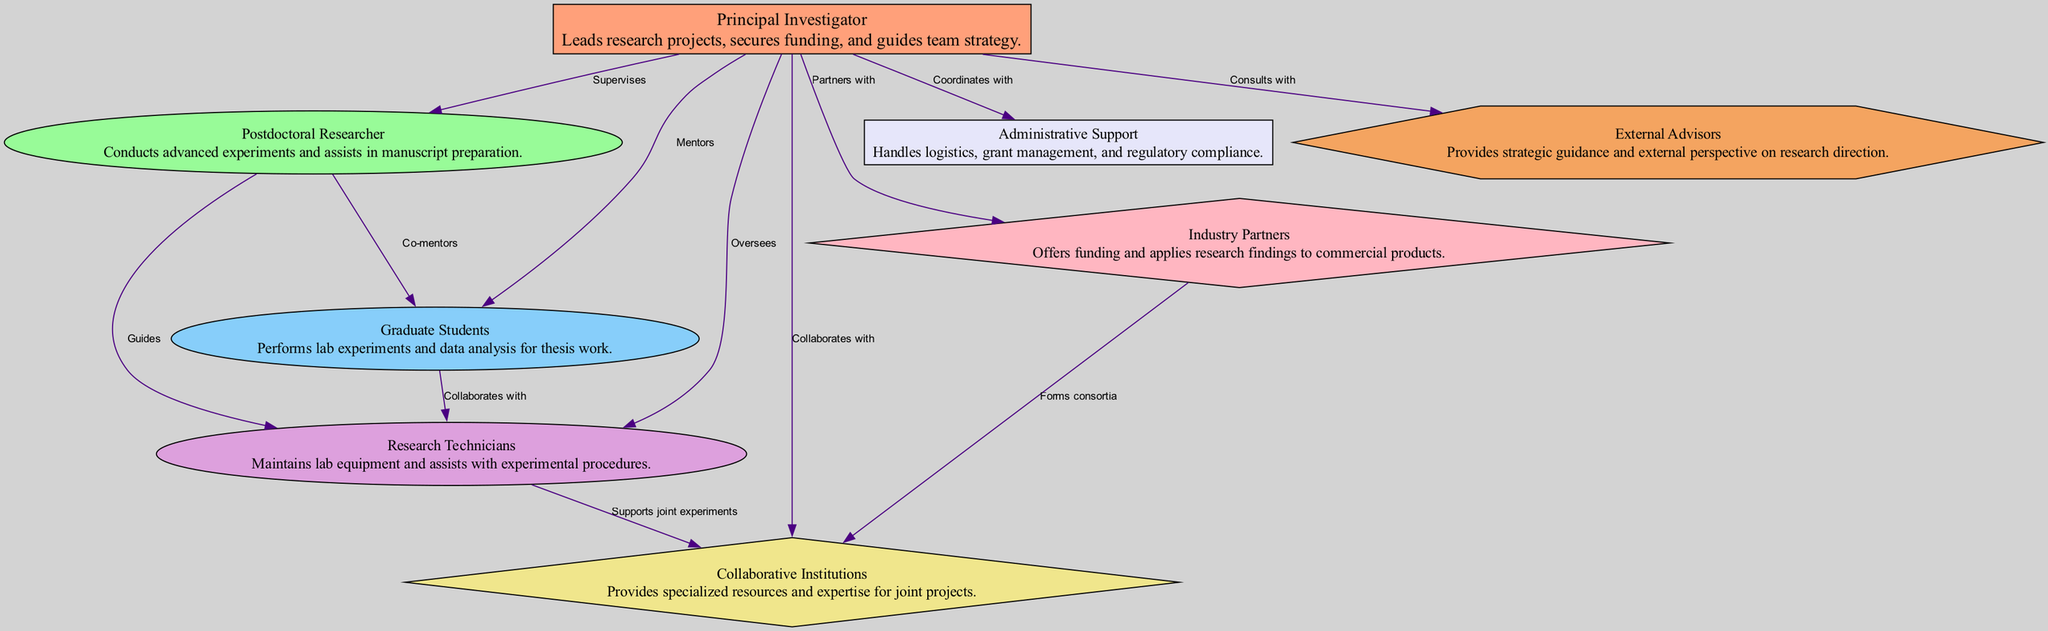What role does the Principal Investigator have? The diagram describes the Principal Investigator as leading research projects, securing funding, and guiding team strategy, which directly addresses the role attributed to this node.
Answer: Leads research projects Who does the Postdoctoral Researcher co-mentor? According to the diagram, the Postdoctoral Researcher has a direct edge labeled "Co-mentors" pointing to the Graduate Students, indicating a mentoring relationship.
Answer: Graduate Students How many nodes are there in the diagram? By counting each unique entity shown in the diagram, we find a total of eight nodes present in the organizational structure: Principal Investigator, Postdoctoral Researcher, Graduate Students, Research Technicians, Collaborative Institutions, Industry Partners, Administrative Support, and External Advisors.
Answer: Eight What relationship exists between Research Technicians and Graduate Students? The diagram indicates a collaborative relationship, as denoted by the edge labeled "Collaborates with," showing the interaction between these two nodes.
Answer: Collaborates with Which entities does the Principal Investigator coordinate with? The Principal Investigator coordinates with Administrative Support, as indicated by the edge labeled "Coordinates with," depicting the collaborative action between these two nodes in the diagram.
Answer: Administrative Support What primary function do the Industry Partners serve? The diagram states that Industry Partners provide funding and apply research findings to commercial products, outlining their primary function within the team structure.
Answer: Offers funding How many edges are there in the diagram? By examining the connections between the nodes, we find a total of twelve edges present, indicating the various relationships and interactions among the entities.
Answer: Twelve What is the nature of the collaboration between Research Technicians and Collaborative Institutions? The diagram indicates that Research Technicians support joint experiments with Collaborative Institutions, illustrating a specific collaborative function they share.
Answer: Supports joint experiments What type of guidance do External Advisors provide? External Advisors are characterized in the diagram as providing strategic guidance and an external perspective, which clarifies their advisory role in the research context.
Answer: Strategic guidance 